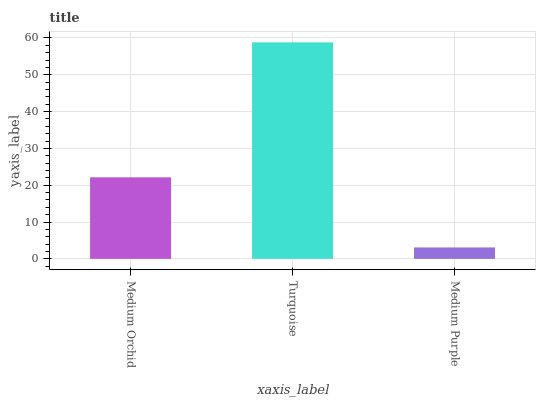Is Medium Purple the minimum?
Answer yes or no. Yes. Is Turquoise the maximum?
Answer yes or no. Yes. Is Turquoise the minimum?
Answer yes or no. No. Is Medium Purple the maximum?
Answer yes or no. No. Is Turquoise greater than Medium Purple?
Answer yes or no. Yes. Is Medium Purple less than Turquoise?
Answer yes or no. Yes. Is Medium Purple greater than Turquoise?
Answer yes or no. No. Is Turquoise less than Medium Purple?
Answer yes or no. No. Is Medium Orchid the high median?
Answer yes or no. Yes. Is Medium Orchid the low median?
Answer yes or no. Yes. Is Turquoise the high median?
Answer yes or no. No. Is Medium Purple the low median?
Answer yes or no. No. 